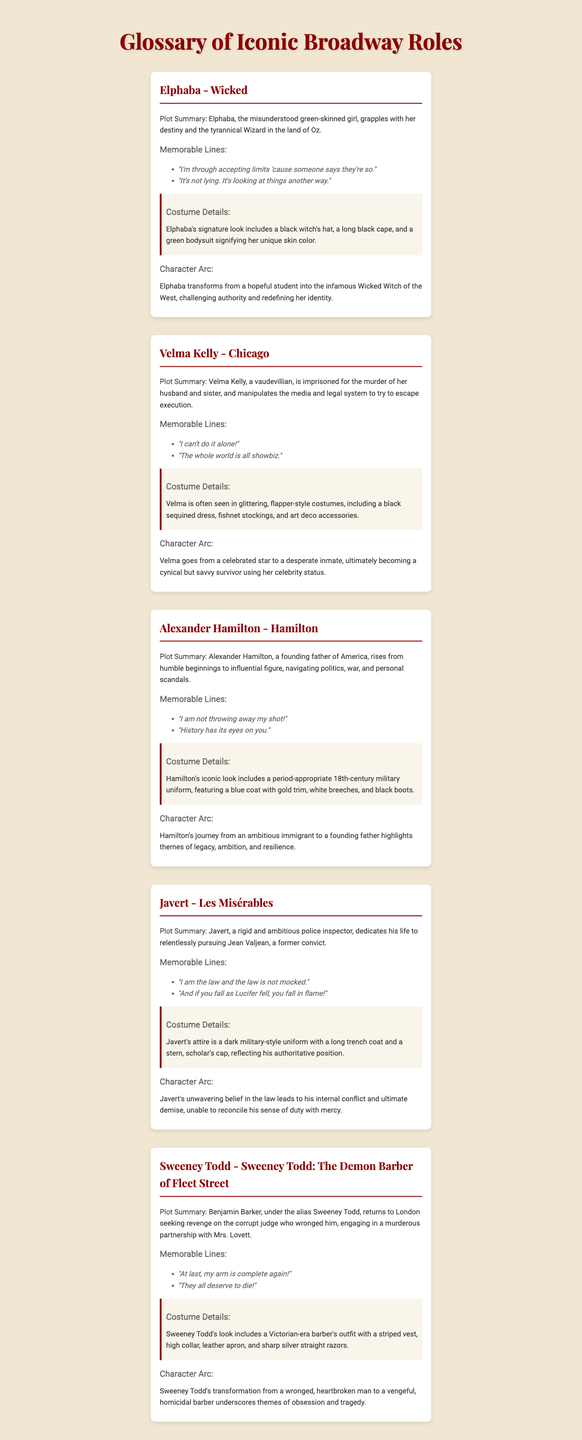What is Elphaba's plot summary? Elphaba is a misunderstood green-skinned girl grappling with her destiny and the tyrannical Wizard in the land of Oz.
Answer: Misunderstood green-skinned girl grappling with destiny What are the memorable lines of Javert? The document lists two memorable lines for Javert, highlighting his unyielding nature and authority.
Answer: "I am the law and the law is not mocked." and "And if you fall as Lucifer fell, you fall in flame!" What costume details are associated with Sweeney Todd? Sweeney Todd's costume includes specific items that reflect his character as a barber in a Victorian-era setting.
Answer: Victorian-era barber's outfit with a striped vest, high collar, leather apron, and sharp silver straight razors How does Velma Kelly's character arc evolve? Velma Kelly's character arc shows her transformation from a celebrated star to a desperate inmate.
Answer: From celebrated star to desperate inmate What is Alexander Hamilton's memorable line? The document mentions two memorable lines attributed to Alexander Hamilton as part of his character's expression of ambition and determination.
Answer: "I am not throwing away my shot!" What role does Javert play in Les Misérables? The document specifies the character role of Javert within the context of the storyline.
Answer: Police inspector How many iconic Broadway roles are featured in the document? The number of roles listed gives an overview of the document's breadth regarding iconic characters.
Answer: Five roles What does Elphaba's costume signify? The description of Elphaba's costume details how her appearance reflects her character's identity and powers in the story.
Answer: Unique skin color What theme is highlighted in Sweeney Todd's character arc? The document outlines a significant thematic element that shapes Sweeney Todd's evolution throughout the narrative.
Answer: Obsession and tragedy 